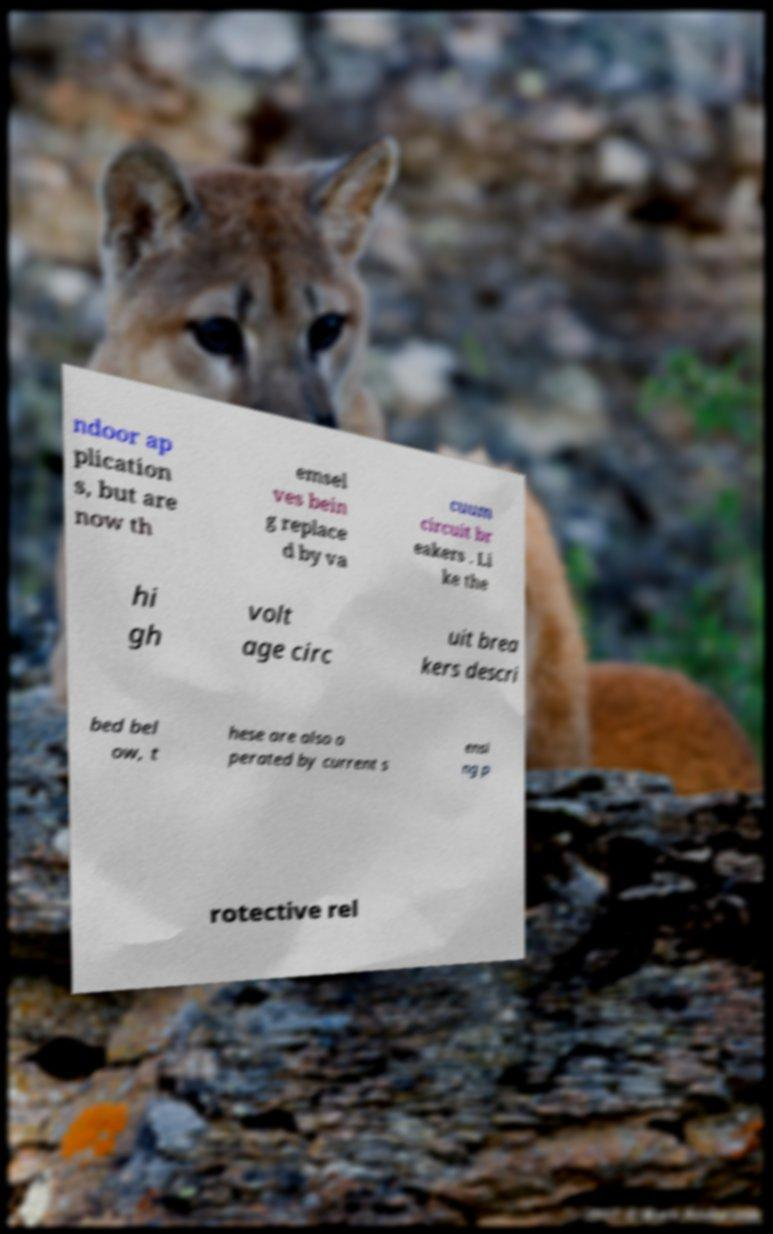Could you assist in decoding the text presented in this image and type it out clearly? ndoor ap plication s, but are now th emsel ves bein g replace d by va cuum circuit br eakers . Li ke the hi gh volt age circ uit brea kers descri bed bel ow, t hese are also o perated by current s ensi ng p rotective rel 